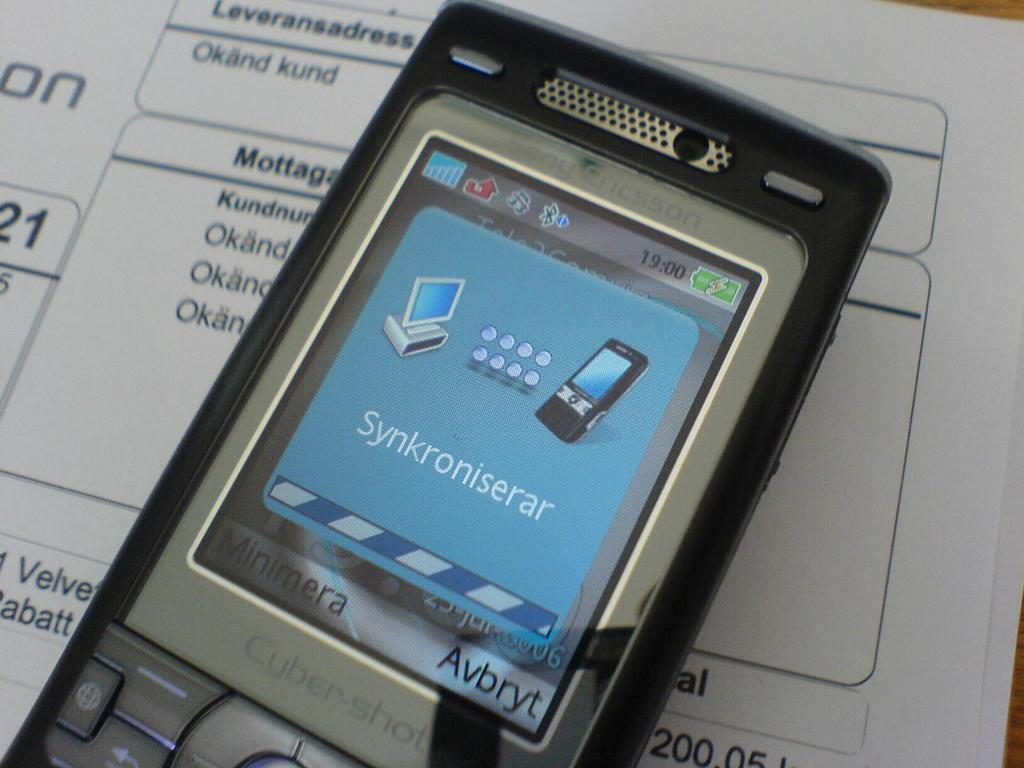<image>
Create a compact narrative representing the image presented. A phone, featuring a Cyber-shot camera, displays a screen with the text "synkroniserar." 